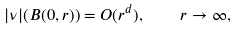<formula> <loc_0><loc_0><loc_500><loc_500>| \nu | ( B ( 0 , r ) ) = O ( r ^ { d } ) , \quad r \to \infty ,</formula> 